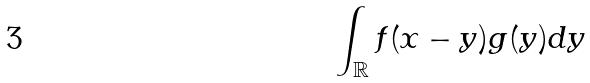Convert formula to latex. <formula><loc_0><loc_0><loc_500><loc_500>\int _ { \mathbb { R } } f ( x - y ) g ( y ) d y</formula> 